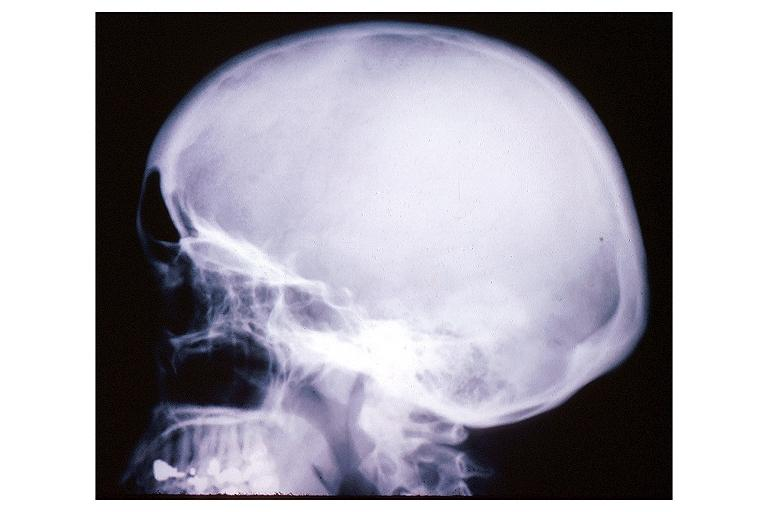where is this?
Answer the question using a single word or phrase. Oral 